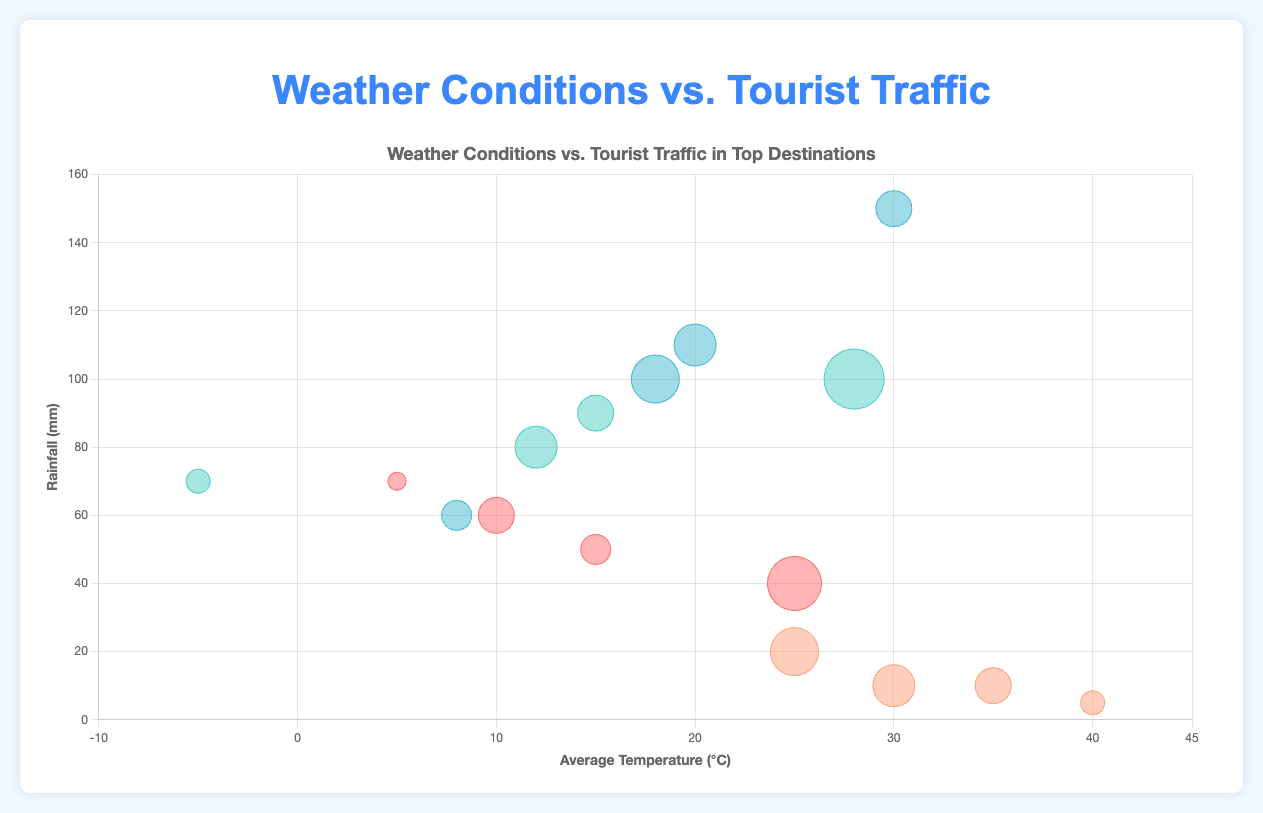What's the title of the chart? The title is displayed at the top of the chart in bold.
Answer: Weather Conditions vs. Tourist Traffic in Top Destinations What does the x-axis represent? The x-axis title indicates it measures the average temperature in °C, ranging from -10 to 45.
Answer: Average Temperature (°C) What does the size of each bubble represent? The tooltip and legend information suggest that the size of each bubble is proportional to the tourist traffic for each destination and season.
Answer: Tourist Traffic Which destination has the highest tourist traffic in the Summer season? By comparing all bubbles labeled for the Summer season, the largest bubble is for New York, indicating it has the highest tourist traffic.
Answer: New York Which season has the lowest average temperature in New York? By examining the x-axis positions for New York's seasons, the Winter bubble has the lowest x-value at -5°C.
Answer: Winter How does the average rainfall in Summer compare between Tokyo and Dubai? By comparing the y-axis positions of the Summer bubbles for Tokyo and Dubai, Tokyo’s bubble is much higher, indicating more rainfall at 150 mm compared to Dubai's 5 mm.
Answer: Tokyo has significantly more rainfall in Summer than Dubai Which season in Paris has the highest rainfall? The bubble with the highest y-axis position for Paris is in Winter at 70 mm.
Answer: Winter What is the average temperature difference between Spring and Fall in Paris? The x-axis positions for Paris in Spring and Fall are 15°C and 10°C, respectively. The difference is calculated as 15 - 10.
Answer: 5°C In which season does Dubai experience the highest tourist traffic, and what is the approximate value? Comparing all seasonal bubbles for Dubai, the Winter season has the largest size proportional to its tourist traffic, which is 8.
Answer: Winter, 8 What is the range of average temperatures for New York across all seasons? New York's bubbles on the x-axis range from -5°C in Winter to 28°C in Summer. The range is calculated as 28 - (-5).
Answer: 33°C 